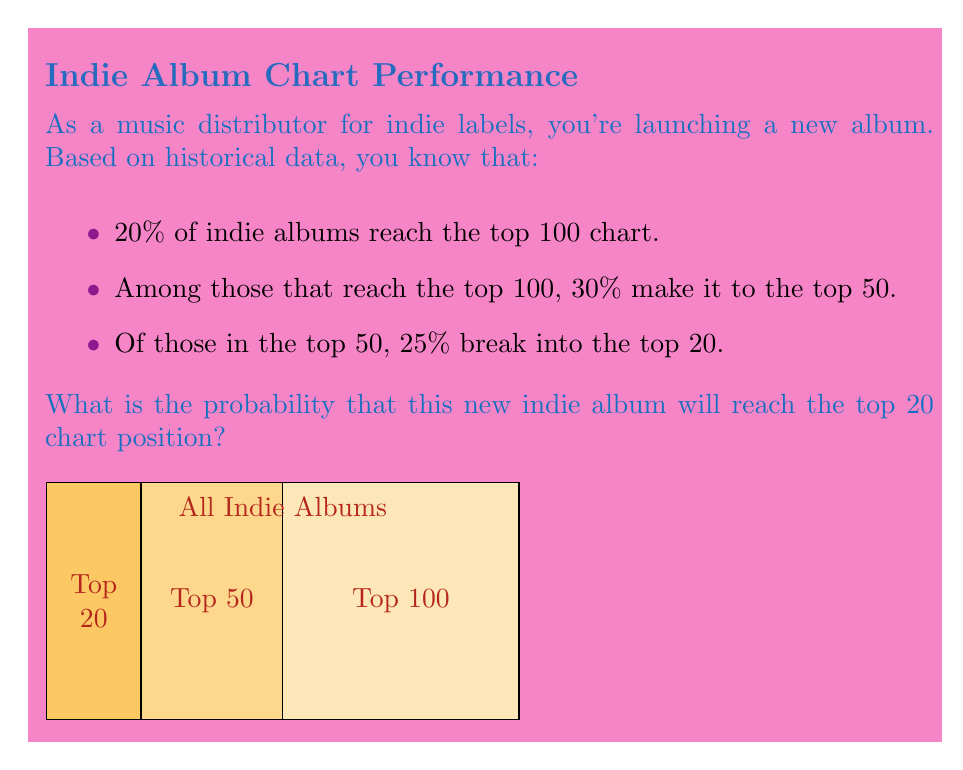Help me with this question. Let's approach this step-by-step using the concept of conditional probability:

1) First, let's define our events:
   A: The album reaches the top 100
   B: The album reaches the top 50, given it's in the top 100
   C: The album reaches the top 20, given it's in the top 50

2) We're given the following probabilities:
   $P(A) = 0.20$
   $P(B|A) = 0.30$
   $P(C|B) = 0.25$

3) We want to find $P(A \cap B \cap C)$, which is the probability of all three events occurring.

4) Using the chain rule of probability:
   $P(A \cap B \cap C) = P(A) \cdot P(B|A) \cdot P(C|B)$

5) Substituting the values:
   $P(A \cap B \cap C) = 0.20 \cdot 0.30 \cdot 0.25$

6) Calculating:
   $P(A \cap B \cap C) = 0.015$

Therefore, the probability that the new indie album will reach the top 20 chart position is 0.015 or 1.5%.
Answer: 0.015 